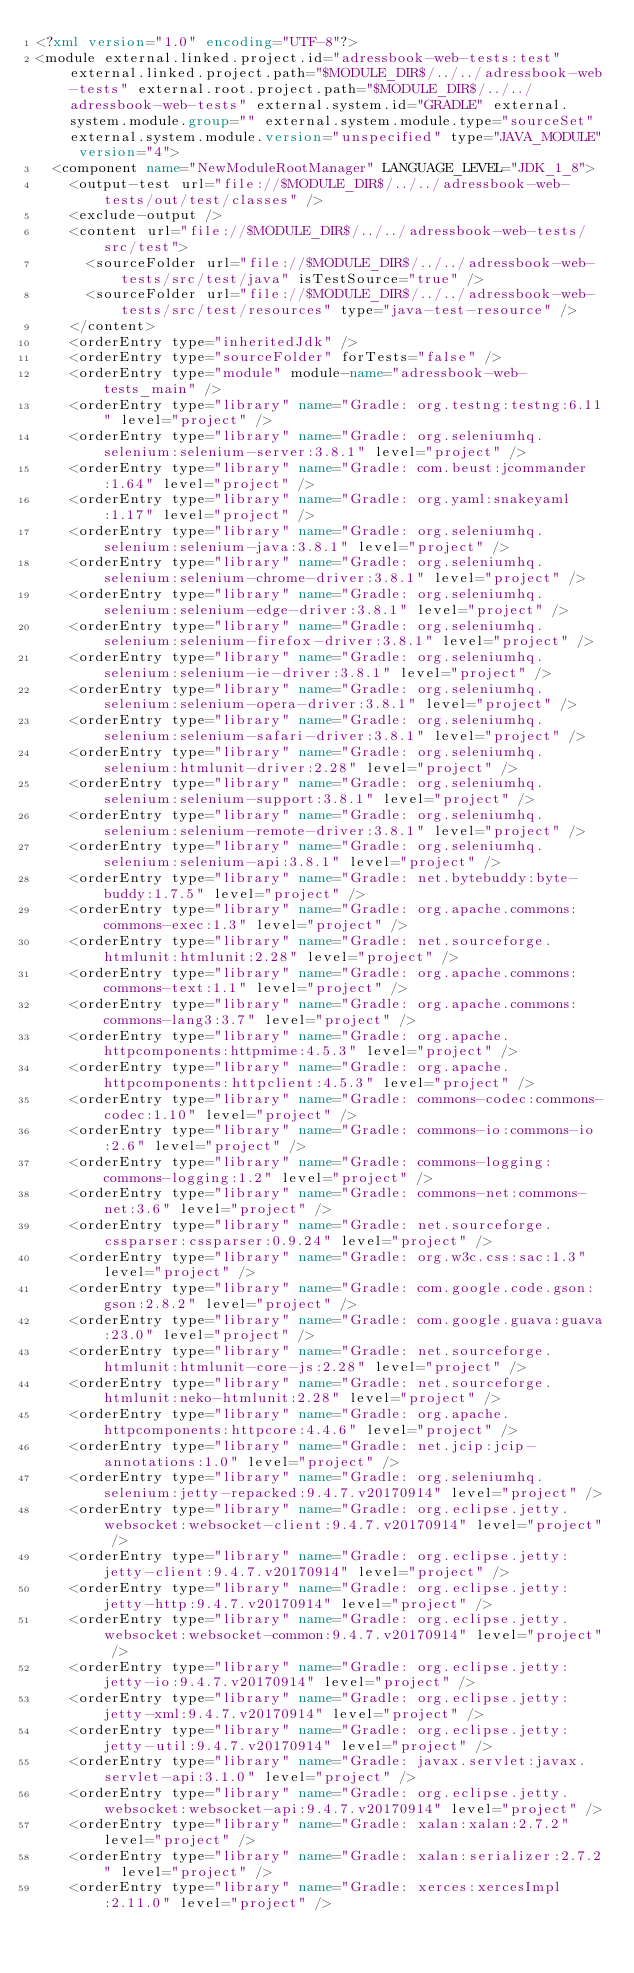Convert code to text. <code><loc_0><loc_0><loc_500><loc_500><_XML_><?xml version="1.0" encoding="UTF-8"?>
<module external.linked.project.id="adressbook-web-tests:test" external.linked.project.path="$MODULE_DIR$/../../adressbook-web-tests" external.root.project.path="$MODULE_DIR$/../../adressbook-web-tests" external.system.id="GRADLE" external.system.module.group="" external.system.module.type="sourceSet" external.system.module.version="unspecified" type="JAVA_MODULE" version="4">
  <component name="NewModuleRootManager" LANGUAGE_LEVEL="JDK_1_8">
    <output-test url="file://$MODULE_DIR$/../../adressbook-web-tests/out/test/classes" />
    <exclude-output />
    <content url="file://$MODULE_DIR$/../../adressbook-web-tests/src/test">
      <sourceFolder url="file://$MODULE_DIR$/../../adressbook-web-tests/src/test/java" isTestSource="true" />
      <sourceFolder url="file://$MODULE_DIR$/../../adressbook-web-tests/src/test/resources" type="java-test-resource" />
    </content>
    <orderEntry type="inheritedJdk" />
    <orderEntry type="sourceFolder" forTests="false" />
    <orderEntry type="module" module-name="adressbook-web-tests_main" />
    <orderEntry type="library" name="Gradle: org.testng:testng:6.11" level="project" />
    <orderEntry type="library" name="Gradle: org.seleniumhq.selenium:selenium-server:3.8.1" level="project" />
    <orderEntry type="library" name="Gradle: com.beust:jcommander:1.64" level="project" />
    <orderEntry type="library" name="Gradle: org.yaml:snakeyaml:1.17" level="project" />
    <orderEntry type="library" name="Gradle: org.seleniumhq.selenium:selenium-java:3.8.1" level="project" />
    <orderEntry type="library" name="Gradle: org.seleniumhq.selenium:selenium-chrome-driver:3.8.1" level="project" />
    <orderEntry type="library" name="Gradle: org.seleniumhq.selenium:selenium-edge-driver:3.8.1" level="project" />
    <orderEntry type="library" name="Gradle: org.seleniumhq.selenium:selenium-firefox-driver:3.8.1" level="project" />
    <orderEntry type="library" name="Gradle: org.seleniumhq.selenium:selenium-ie-driver:3.8.1" level="project" />
    <orderEntry type="library" name="Gradle: org.seleniumhq.selenium:selenium-opera-driver:3.8.1" level="project" />
    <orderEntry type="library" name="Gradle: org.seleniumhq.selenium:selenium-safari-driver:3.8.1" level="project" />
    <orderEntry type="library" name="Gradle: org.seleniumhq.selenium:htmlunit-driver:2.28" level="project" />
    <orderEntry type="library" name="Gradle: org.seleniumhq.selenium:selenium-support:3.8.1" level="project" />
    <orderEntry type="library" name="Gradle: org.seleniumhq.selenium:selenium-remote-driver:3.8.1" level="project" />
    <orderEntry type="library" name="Gradle: org.seleniumhq.selenium:selenium-api:3.8.1" level="project" />
    <orderEntry type="library" name="Gradle: net.bytebuddy:byte-buddy:1.7.5" level="project" />
    <orderEntry type="library" name="Gradle: org.apache.commons:commons-exec:1.3" level="project" />
    <orderEntry type="library" name="Gradle: net.sourceforge.htmlunit:htmlunit:2.28" level="project" />
    <orderEntry type="library" name="Gradle: org.apache.commons:commons-text:1.1" level="project" />
    <orderEntry type="library" name="Gradle: org.apache.commons:commons-lang3:3.7" level="project" />
    <orderEntry type="library" name="Gradle: org.apache.httpcomponents:httpmime:4.5.3" level="project" />
    <orderEntry type="library" name="Gradle: org.apache.httpcomponents:httpclient:4.5.3" level="project" />
    <orderEntry type="library" name="Gradle: commons-codec:commons-codec:1.10" level="project" />
    <orderEntry type="library" name="Gradle: commons-io:commons-io:2.6" level="project" />
    <orderEntry type="library" name="Gradle: commons-logging:commons-logging:1.2" level="project" />
    <orderEntry type="library" name="Gradle: commons-net:commons-net:3.6" level="project" />
    <orderEntry type="library" name="Gradle: net.sourceforge.cssparser:cssparser:0.9.24" level="project" />
    <orderEntry type="library" name="Gradle: org.w3c.css:sac:1.3" level="project" />
    <orderEntry type="library" name="Gradle: com.google.code.gson:gson:2.8.2" level="project" />
    <orderEntry type="library" name="Gradle: com.google.guava:guava:23.0" level="project" />
    <orderEntry type="library" name="Gradle: net.sourceforge.htmlunit:htmlunit-core-js:2.28" level="project" />
    <orderEntry type="library" name="Gradle: net.sourceforge.htmlunit:neko-htmlunit:2.28" level="project" />
    <orderEntry type="library" name="Gradle: org.apache.httpcomponents:httpcore:4.4.6" level="project" />
    <orderEntry type="library" name="Gradle: net.jcip:jcip-annotations:1.0" level="project" />
    <orderEntry type="library" name="Gradle: org.seleniumhq.selenium:jetty-repacked:9.4.7.v20170914" level="project" />
    <orderEntry type="library" name="Gradle: org.eclipse.jetty.websocket:websocket-client:9.4.7.v20170914" level="project" />
    <orderEntry type="library" name="Gradle: org.eclipse.jetty:jetty-client:9.4.7.v20170914" level="project" />
    <orderEntry type="library" name="Gradle: org.eclipse.jetty:jetty-http:9.4.7.v20170914" level="project" />
    <orderEntry type="library" name="Gradle: org.eclipse.jetty.websocket:websocket-common:9.4.7.v20170914" level="project" />
    <orderEntry type="library" name="Gradle: org.eclipse.jetty:jetty-io:9.4.7.v20170914" level="project" />
    <orderEntry type="library" name="Gradle: org.eclipse.jetty:jetty-xml:9.4.7.v20170914" level="project" />
    <orderEntry type="library" name="Gradle: org.eclipse.jetty:jetty-util:9.4.7.v20170914" level="project" />
    <orderEntry type="library" name="Gradle: javax.servlet:javax.servlet-api:3.1.0" level="project" />
    <orderEntry type="library" name="Gradle: org.eclipse.jetty.websocket:websocket-api:9.4.7.v20170914" level="project" />
    <orderEntry type="library" name="Gradle: xalan:xalan:2.7.2" level="project" />
    <orderEntry type="library" name="Gradle: xalan:serializer:2.7.2" level="project" />
    <orderEntry type="library" name="Gradle: xerces:xercesImpl:2.11.0" level="project" /></code> 